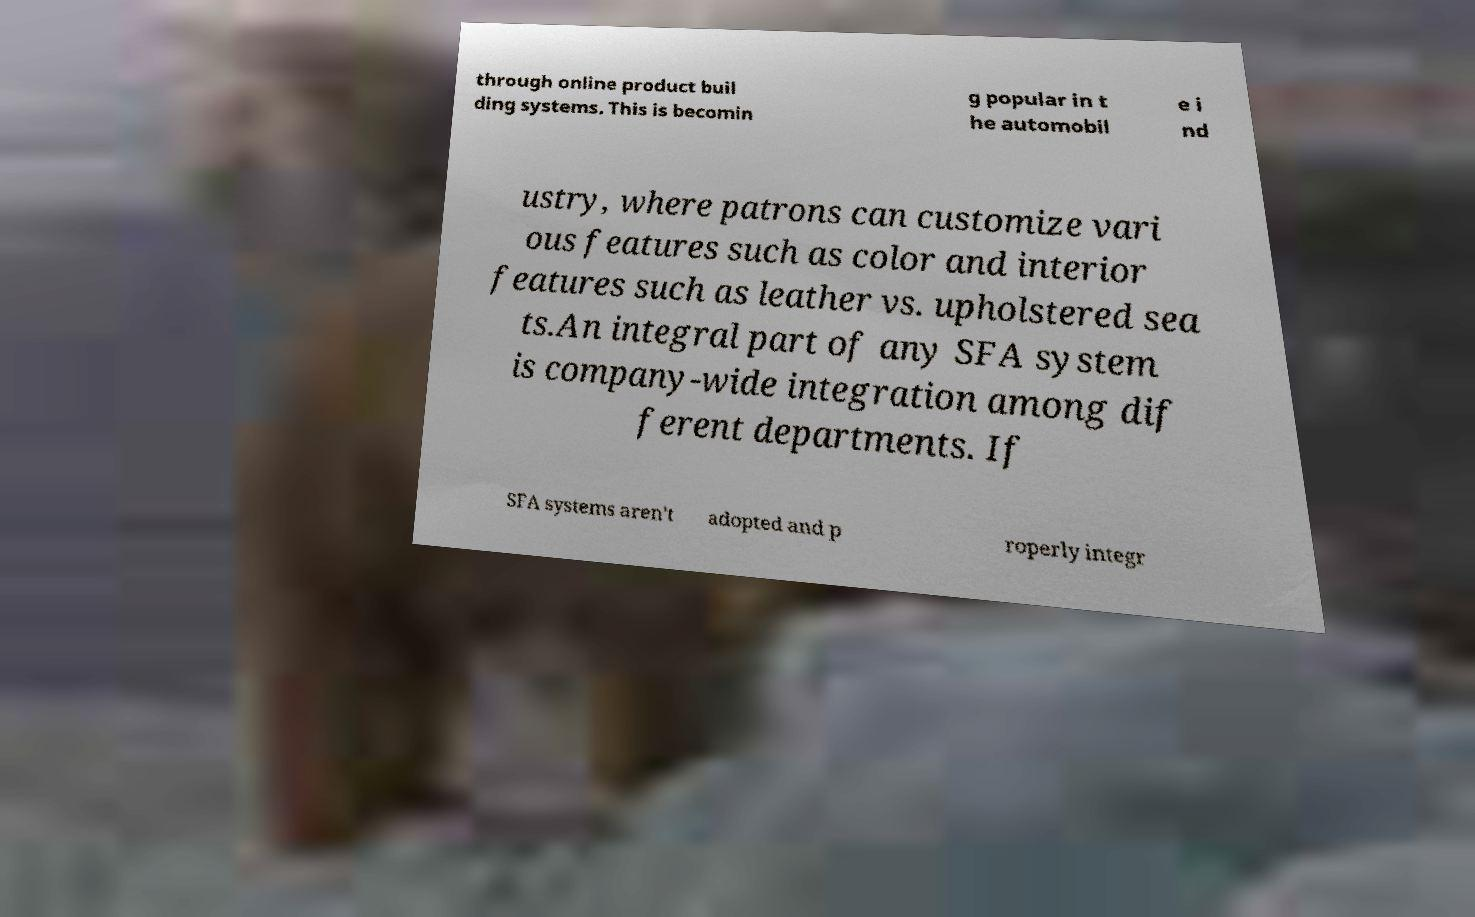There's text embedded in this image that I need extracted. Can you transcribe it verbatim? through online product buil ding systems. This is becomin g popular in t he automobil e i nd ustry, where patrons can customize vari ous features such as color and interior features such as leather vs. upholstered sea ts.An integral part of any SFA system is company-wide integration among dif ferent departments. If SFA systems aren't adopted and p roperly integr 